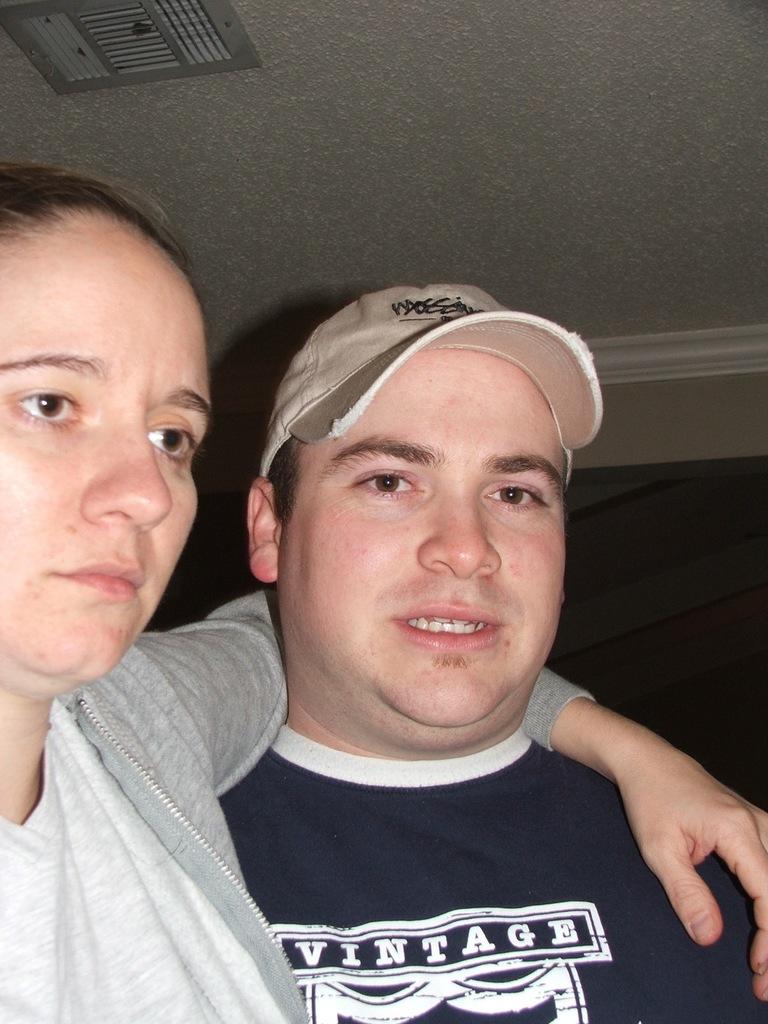What are the first two letters on the man´s cap?
Your answer should be very brief. Unanswerable. 